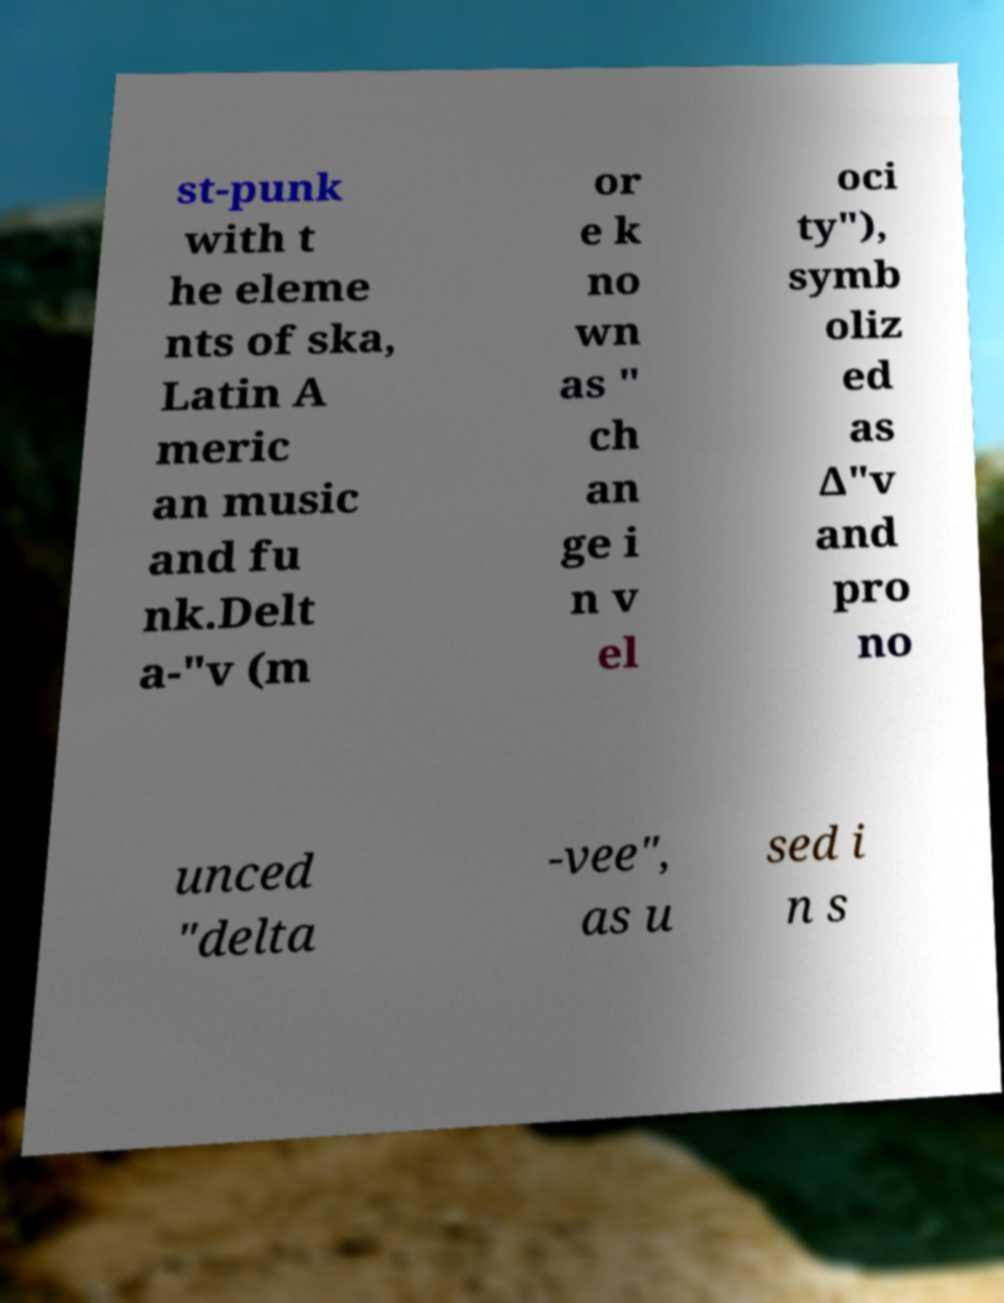Can you read and provide the text displayed in the image?This photo seems to have some interesting text. Can you extract and type it out for me? st-punk with t he eleme nts of ska, Latin A meric an music and fu nk.Delt a-"v (m or e k no wn as " ch an ge i n v el oci ty"), symb oliz ed as ∆"v and pro no unced "delta -vee", as u sed i n s 